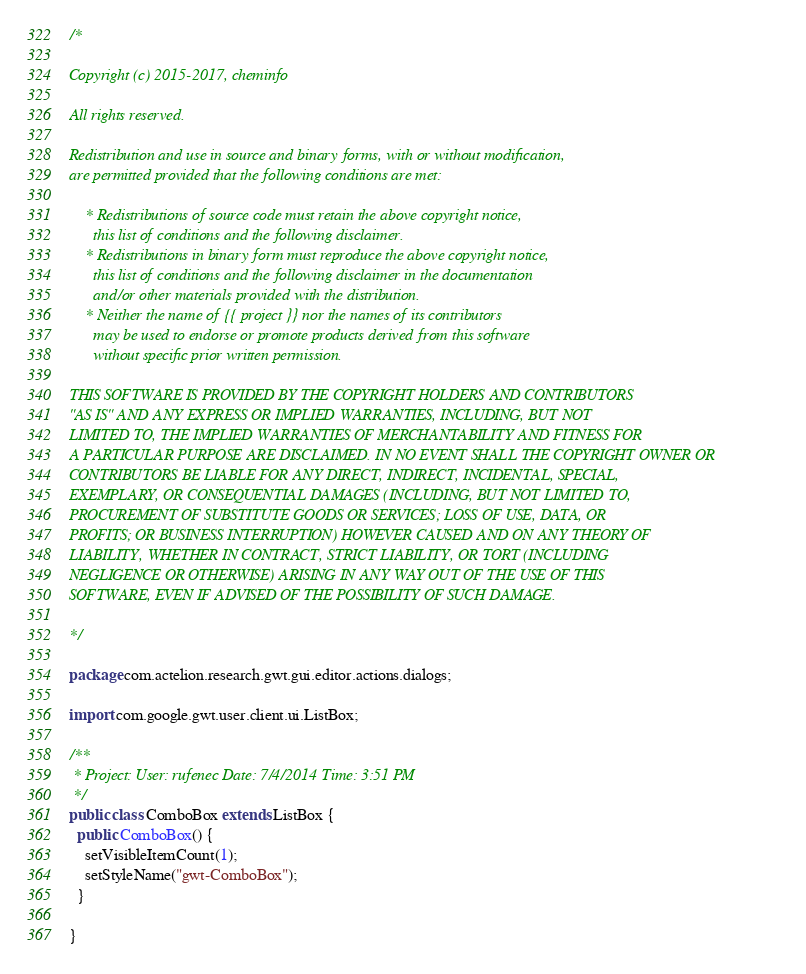<code> <loc_0><loc_0><loc_500><loc_500><_Java_>/*

Copyright (c) 2015-2017, cheminfo

All rights reserved.

Redistribution and use in source and binary forms, with or without modification,
are permitted provided that the following conditions are met:

    * Redistributions of source code must retain the above copyright notice,
      this list of conditions and the following disclaimer.
    * Redistributions in binary form must reproduce the above copyright notice,
      this list of conditions and the following disclaimer in the documentation
      and/or other materials provided with the distribution.
    * Neither the name of {{ project }} nor the names of its contributors
      may be used to endorse or promote products derived from this software
      without specific prior written permission.

THIS SOFTWARE IS PROVIDED BY THE COPYRIGHT HOLDERS AND CONTRIBUTORS
"AS IS" AND ANY EXPRESS OR IMPLIED WARRANTIES, INCLUDING, BUT NOT
LIMITED TO, THE IMPLIED WARRANTIES OF MERCHANTABILITY AND FITNESS FOR
A PARTICULAR PURPOSE ARE DISCLAIMED. IN NO EVENT SHALL THE COPYRIGHT OWNER OR
CONTRIBUTORS BE LIABLE FOR ANY DIRECT, INDIRECT, INCIDENTAL, SPECIAL,
EXEMPLARY, OR CONSEQUENTIAL DAMAGES (INCLUDING, BUT NOT LIMITED TO,
PROCUREMENT OF SUBSTITUTE GOODS OR SERVICES; LOSS OF USE, DATA, OR
PROFITS; OR BUSINESS INTERRUPTION) HOWEVER CAUSED AND ON ANY THEORY OF
LIABILITY, WHETHER IN CONTRACT, STRICT LIABILITY, OR TORT (INCLUDING
NEGLIGENCE OR OTHERWISE) ARISING IN ANY WAY OUT OF THE USE OF THIS
SOFTWARE, EVEN IF ADVISED OF THE POSSIBILITY OF SUCH DAMAGE.

*/

package com.actelion.research.gwt.gui.editor.actions.dialogs;

import com.google.gwt.user.client.ui.ListBox;

/**
 * Project: User: rufenec Date: 7/4/2014 Time: 3:51 PM
 */
public class ComboBox extends ListBox {
  public ComboBox() {
    setVisibleItemCount(1);
    setStyleName("gwt-ComboBox");
  }

}
</code> 